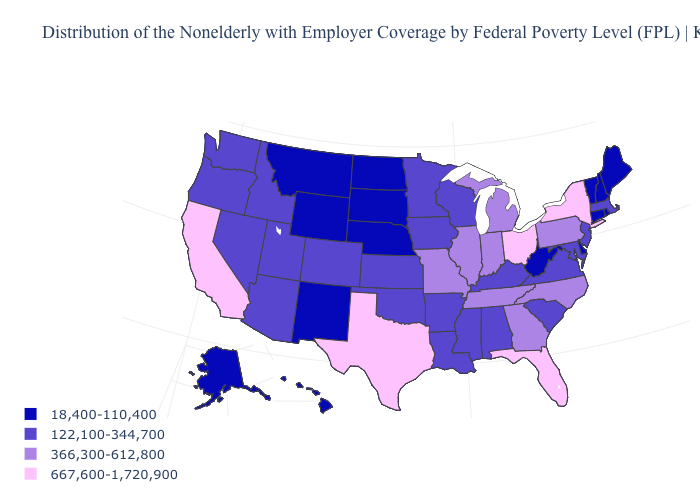Name the states that have a value in the range 122,100-344,700?
Short answer required. Alabama, Arizona, Arkansas, Colorado, Idaho, Iowa, Kansas, Kentucky, Louisiana, Maryland, Massachusetts, Minnesota, Mississippi, Nevada, New Jersey, Oklahoma, Oregon, South Carolina, Utah, Virginia, Washington, Wisconsin. Is the legend a continuous bar?
Short answer required. No. Name the states that have a value in the range 667,600-1,720,900?
Answer briefly. California, Florida, New York, Ohio, Texas. What is the value of Wisconsin?
Short answer required. 122,100-344,700. What is the value of Wisconsin?
Give a very brief answer. 122,100-344,700. What is the highest value in the USA?
Answer briefly. 667,600-1,720,900. What is the value of Nevada?
Give a very brief answer. 122,100-344,700. What is the lowest value in the USA?
Concise answer only. 18,400-110,400. Name the states that have a value in the range 366,300-612,800?
Short answer required. Georgia, Illinois, Indiana, Michigan, Missouri, North Carolina, Pennsylvania, Tennessee. Is the legend a continuous bar?
Keep it brief. No. Name the states that have a value in the range 18,400-110,400?
Write a very short answer. Alaska, Connecticut, Delaware, Hawaii, Maine, Montana, Nebraska, New Hampshire, New Mexico, North Dakota, Rhode Island, South Dakota, Vermont, West Virginia, Wyoming. Does Hawaii have the lowest value in the USA?
Give a very brief answer. Yes. Which states hav the highest value in the MidWest?
Short answer required. Ohio. Which states have the lowest value in the USA?
Quick response, please. Alaska, Connecticut, Delaware, Hawaii, Maine, Montana, Nebraska, New Hampshire, New Mexico, North Dakota, Rhode Island, South Dakota, Vermont, West Virginia, Wyoming. Does Virginia have a higher value than New Hampshire?
Be succinct. Yes. 